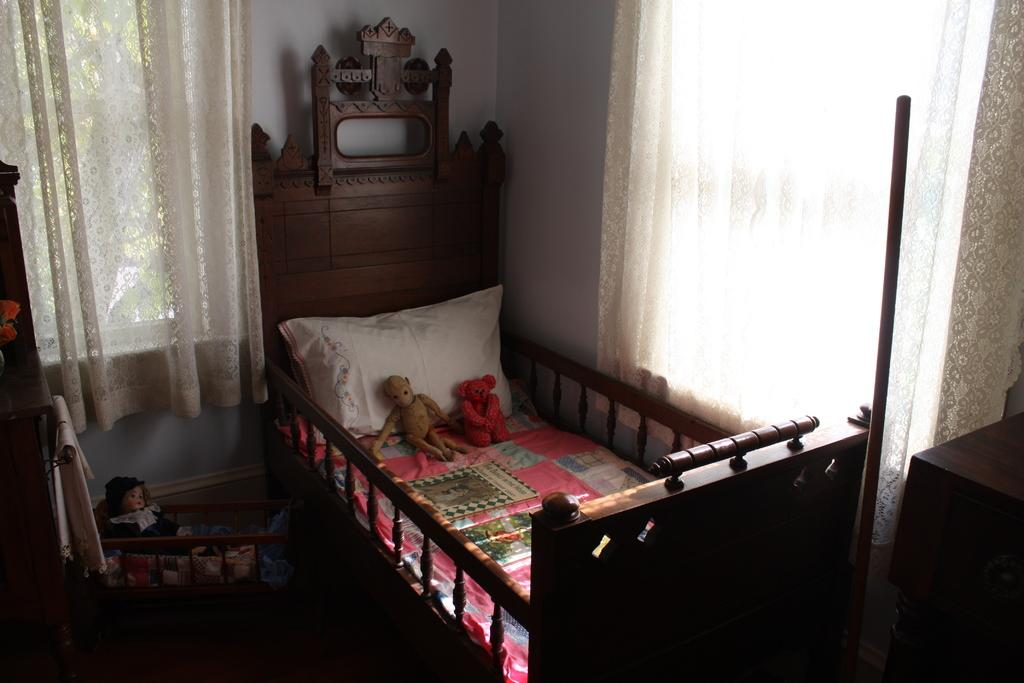What piece of furniture is present in the image? There is a bed in the image. What is placed on the bed? There is a pillow and two toys on the bed. Are there any additional toys in the image? Yes, there is an additional toy beside the bed. What can be seen in the background of the image? There is a curtain and a wall visible in the background of the image. What type of sweater is the person wearing during the meeting in the image? There is no person or meeting present in the image, so it is not possible to determine what type of sweater they might be wearing. 